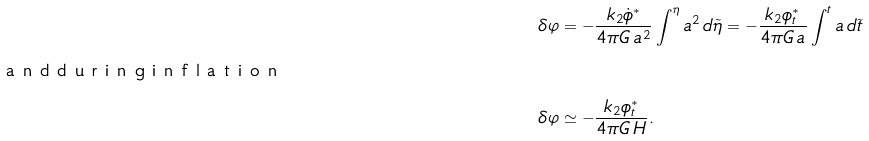<formula> <loc_0><loc_0><loc_500><loc_500>\delta \varphi & = - \frac { k _ { 2 } \dot { \phi } ^ { \ast } } { 4 \pi G \, a ^ { 2 } } \int ^ { \eta } a ^ { 2 } \, d \tilde { \eta } = - \frac { k _ { 2 } \phi _ { t } ^ { \ast } } { 4 \pi G \, a } \int ^ { t } a \, d \tilde { t } \\ \intertext { a n d d u r i n g i n f l a t i o n } \delta \varphi & \simeq - \frac { k _ { 2 } \phi _ { t } ^ { \ast } } { 4 \pi G \, H } .</formula> 